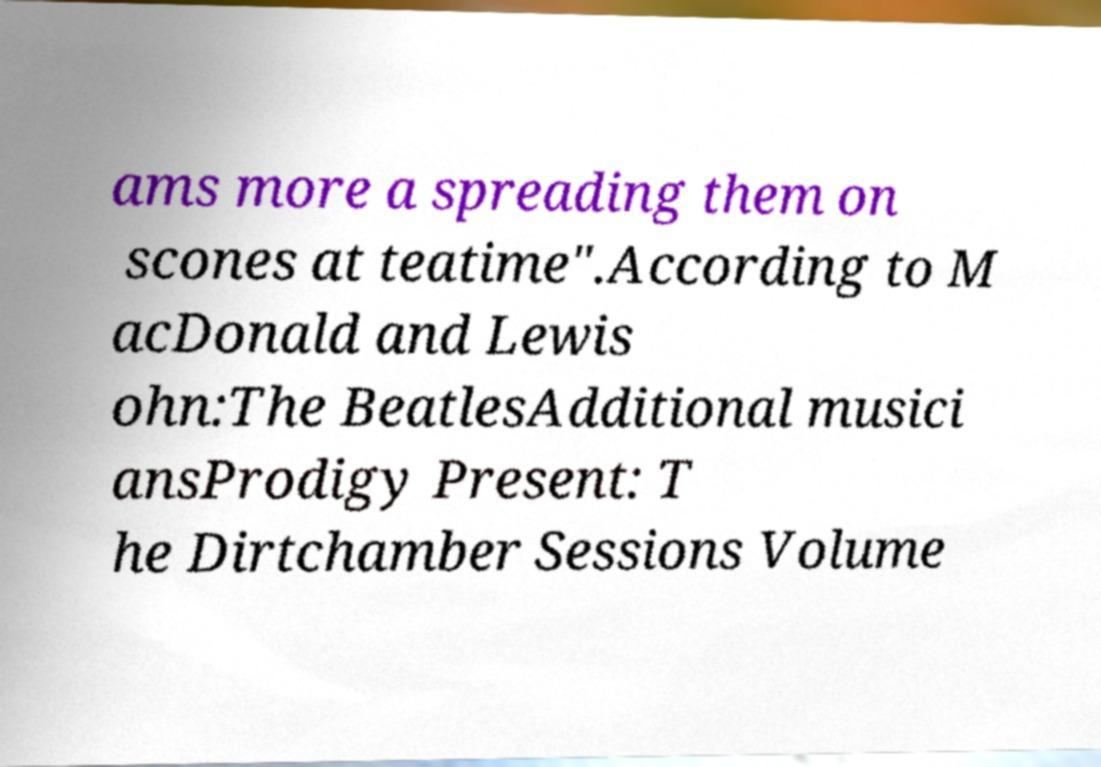Could you assist in decoding the text presented in this image and type it out clearly? ams more a spreading them on scones at teatime".According to M acDonald and Lewis ohn:The BeatlesAdditional musici ansProdigy Present: T he Dirtchamber Sessions Volume 